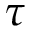<formula> <loc_0><loc_0><loc_500><loc_500>\tau</formula> 